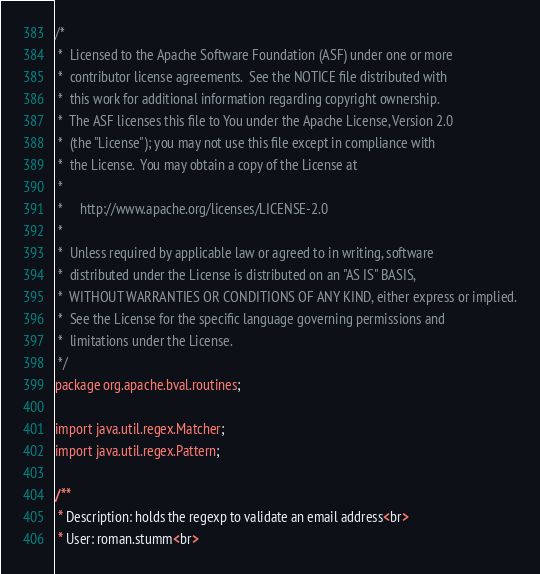<code> <loc_0><loc_0><loc_500><loc_500><_Java_>/*
 *  Licensed to the Apache Software Foundation (ASF) under one or more
 *  contributor license agreements.  See the NOTICE file distributed with
 *  this work for additional information regarding copyright ownership.
 *  The ASF licenses this file to You under the Apache License, Version 2.0
 *  (the "License"); you may not use this file except in compliance with
 *  the License.  You may obtain a copy of the License at
 *
 *     http://www.apache.org/licenses/LICENSE-2.0
 *
 *  Unless required by applicable law or agreed to in writing, software
 *  distributed under the License is distributed on an "AS IS" BASIS,
 *  WITHOUT WARRANTIES OR CONDITIONS OF ANY KIND, either express or implied.
 *  See the License for the specific language governing permissions and
 *  limitations under the License.
 */
package org.apache.bval.routines;

import java.util.regex.Matcher;
import java.util.regex.Pattern;

/**
 * Description: holds the regexp to validate an email address<br>
 * User: roman.stumm<br></code> 